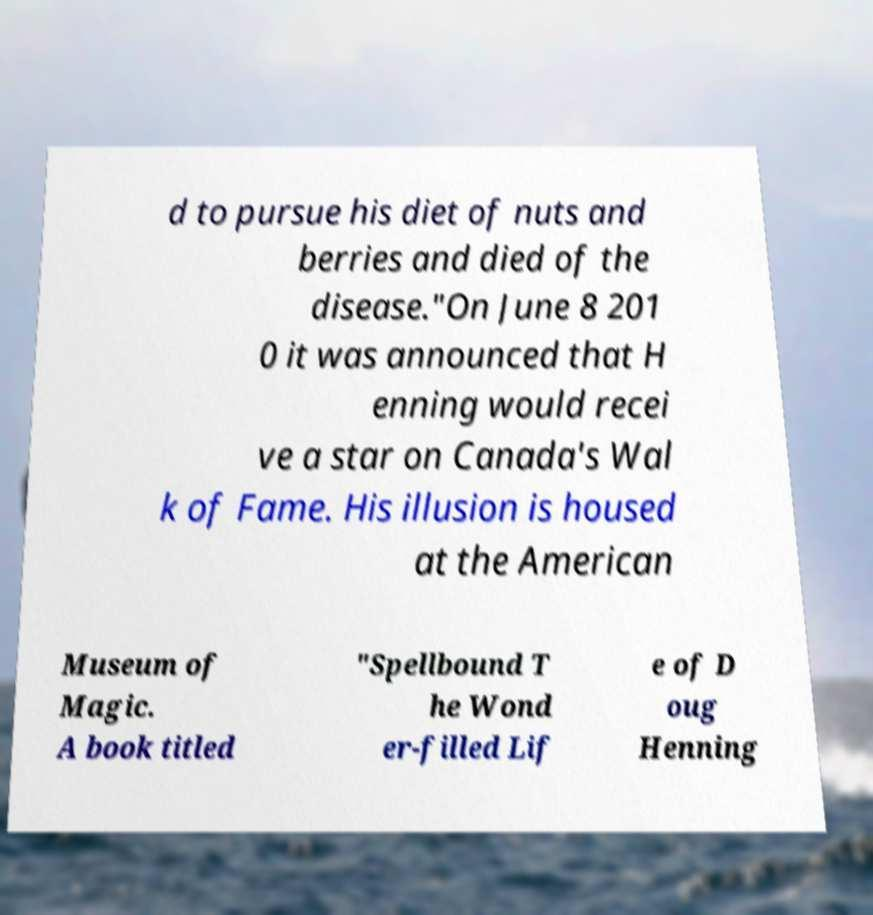Please read and relay the text visible in this image. What does it say? d to pursue his diet of nuts and berries and died of the disease."On June 8 201 0 it was announced that H enning would recei ve a star on Canada's Wal k of Fame. His illusion is housed at the American Museum of Magic. A book titled "Spellbound T he Wond er-filled Lif e of D oug Henning 